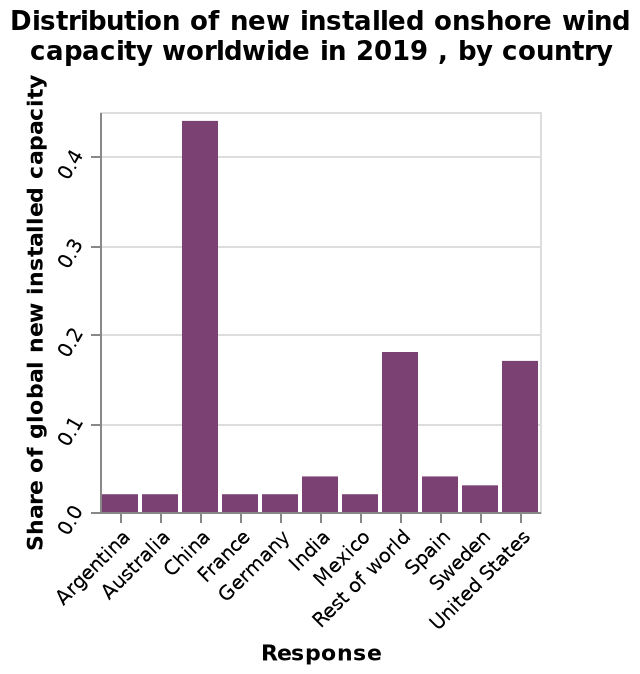<image>
Describe the following image in detail Here a bar chart is titled Distribution of new installed onshore wind capacity worldwide in 2019 , by country. The x-axis plots Response using a categorical scale starting with Argentina and ending with United States. On the y-axis, Share of global new installed capacity is measured. What is plotted on the x-axis? Response using a categorical scale starting with Argentina and ending with United States is plotted on the x-axis. 